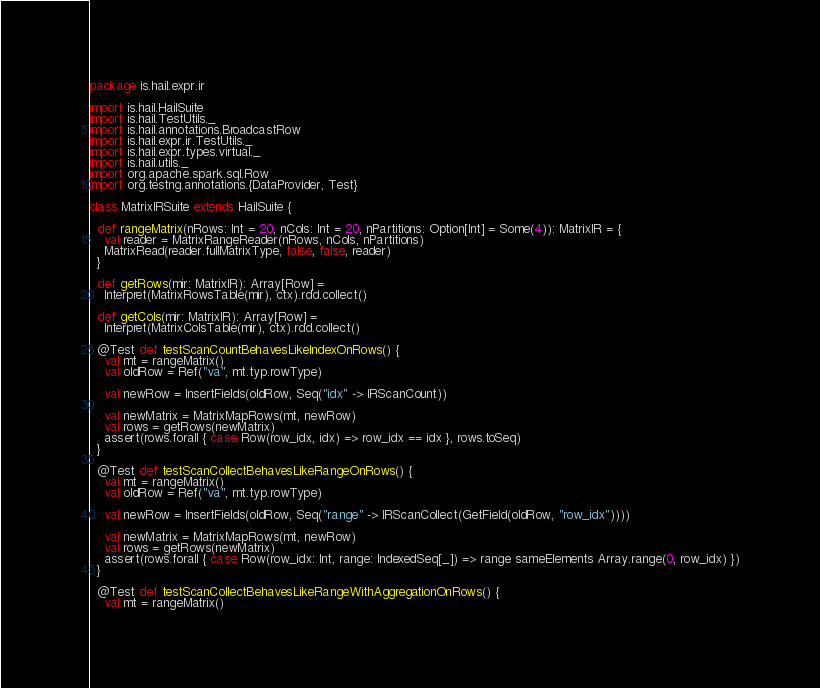Convert code to text. <code><loc_0><loc_0><loc_500><loc_500><_Scala_>package is.hail.expr.ir

import is.hail.HailSuite
import is.hail.TestUtils._
import is.hail.annotations.BroadcastRow
import is.hail.expr.ir.TestUtils._
import is.hail.expr.types.virtual._
import is.hail.utils._
import org.apache.spark.sql.Row
import org.testng.annotations.{DataProvider, Test}

class MatrixIRSuite extends HailSuite {

  def rangeMatrix(nRows: Int = 20, nCols: Int = 20, nPartitions: Option[Int] = Some(4)): MatrixIR = {
    val reader = MatrixRangeReader(nRows, nCols, nPartitions)
    MatrixRead(reader.fullMatrixType, false, false, reader)
  }

  def getRows(mir: MatrixIR): Array[Row] =
    Interpret(MatrixRowsTable(mir), ctx).rdd.collect()

  def getCols(mir: MatrixIR): Array[Row] =
    Interpret(MatrixColsTable(mir), ctx).rdd.collect()

  @Test def testScanCountBehavesLikeIndexOnRows() {
    val mt = rangeMatrix()
    val oldRow = Ref("va", mt.typ.rowType)

    val newRow = InsertFields(oldRow, Seq("idx" -> IRScanCount))

    val newMatrix = MatrixMapRows(mt, newRow)
    val rows = getRows(newMatrix)
    assert(rows.forall { case Row(row_idx, idx) => row_idx == idx }, rows.toSeq)
  }

  @Test def testScanCollectBehavesLikeRangeOnRows() {
    val mt = rangeMatrix()
    val oldRow = Ref("va", mt.typ.rowType)

    val newRow = InsertFields(oldRow, Seq("range" -> IRScanCollect(GetField(oldRow, "row_idx"))))

    val newMatrix = MatrixMapRows(mt, newRow)
    val rows = getRows(newMatrix)
    assert(rows.forall { case Row(row_idx: Int, range: IndexedSeq[_]) => range sameElements Array.range(0, row_idx) })
  }

  @Test def testScanCollectBehavesLikeRangeWithAggregationOnRows() {
    val mt = rangeMatrix()</code> 